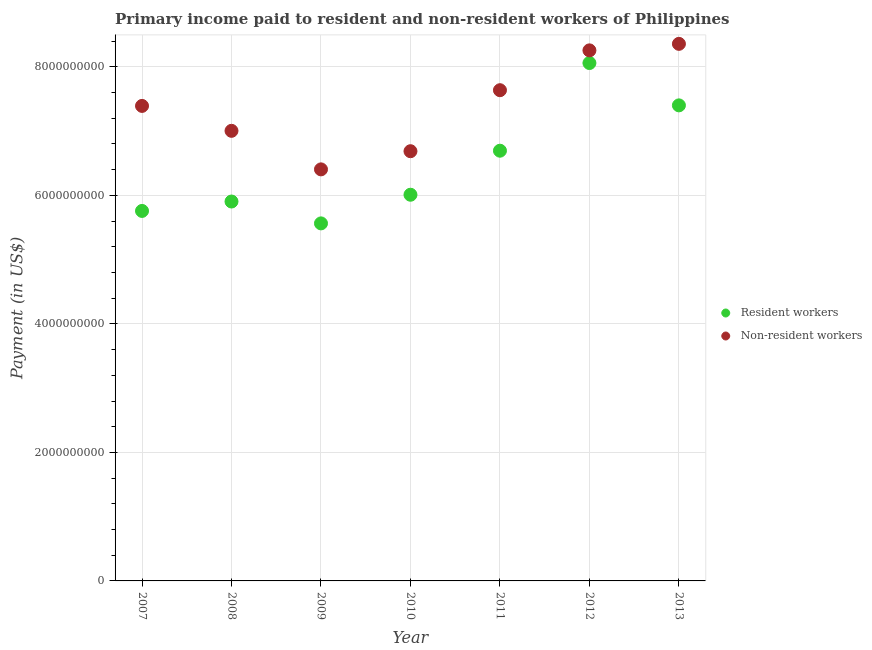Is the number of dotlines equal to the number of legend labels?
Make the answer very short. Yes. What is the payment made to resident workers in 2011?
Your response must be concise. 6.70e+09. Across all years, what is the maximum payment made to resident workers?
Offer a terse response. 8.06e+09. Across all years, what is the minimum payment made to non-resident workers?
Provide a succinct answer. 6.40e+09. What is the total payment made to resident workers in the graph?
Your response must be concise. 4.54e+1. What is the difference between the payment made to non-resident workers in 2009 and that in 2011?
Keep it short and to the point. -1.23e+09. What is the difference between the payment made to non-resident workers in 2011 and the payment made to resident workers in 2007?
Your response must be concise. 1.88e+09. What is the average payment made to resident workers per year?
Provide a succinct answer. 6.48e+09. In the year 2010, what is the difference between the payment made to non-resident workers and payment made to resident workers?
Your answer should be compact. 6.77e+08. What is the ratio of the payment made to non-resident workers in 2009 to that in 2011?
Provide a short and direct response. 0.84. Is the difference between the payment made to resident workers in 2008 and 2011 greater than the difference between the payment made to non-resident workers in 2008 and 2011?
Offer a terse response. No. What is the difference between the highest and the second highest payment made to resident workers?
Your response must be concise. 6.59e+08. What is the difference between the highest and the lowest payment made to resident workers?
Provide a succinct answer. 2.50e+09. Does the payment made to non-resident workers monotonically increase over the years?
Give a very brief answer. No. Is the payment made to resident workers strictly greater than the payment made to non-resident workers over the years?
Provide a short and direct response. No. Is the payment made to resident workers strictly less than the payment made to non-resident workers over the years?
Ensure brevity in your answer.  Yes. How many dotlines are there?
Your response must be concise. 2. Are the values on the major ticks of Y-axis written in scientific E-notation?
Make the answer very short. No. Does the graph contain grids?
Provide a succinct answer. Yes. What is the title of the graph?
Your answer should be very brief. Primary income paid to resident and non-resident workers of Philippines. What is the label or title of the Y-axis?
Your answer should be very brief. Payment (in US$). What is the Payment (in US$) of Resident workers in 2007?
Make the answer very short. 5.76e+09. What is the Payment (in US$) in Non-resident workers in 2007?
Provide a short and direct response. 7.39e+09. What is the Payment (in US$) in Resident workers in 2008?
Make the answer very short. 5.90e+09. What is the Payment (in US$) of Non-resident workers in 2008?
Keep it short and to the point. 7.00e+09. What is the Payment (in US$) in Resident workers in 2009?
Your answer should be very brief. 5.56e+09. What is the Payment (in US$) of Non-resident workers in 2009?
Give a very brief answer. 6.40e+09. What is the Payment (in US$) in Resident workers in 2010?
Offer a very short reply. 6.01e+09. What is the Payment (in US$) in Non-resident workers in 2010?
Keep it short and to the point. 6.69e+09. What is the Payment (in US$) in Resident workers in 2011?
Your answer should be very brief. 6.70e+09. What is the Payment (in US$) in Non-resident workers in 2011?
Your answer should be very brief. 7.64e+09. What is the Payment (in US$) of Resident workers in 2012?
Your answer should be compact. 8.06e+09. What is the Payment (in US$) of Non-resident workers in 2012?
Give a very brief answer. 8.26e+09. What is the Payment (in US$) in Resident workers in 2013?
Provide a short and direct response. 7.40e+09. What is the Payment (in US$) in Non-resident workers in 2013?
Give a very brief answer. 8.36e+09. Across all years, what is the maximum Payment (in US$) of Resident workers?
Provide a short and direct response. 8.06e+09. Across all years, what is the maximum Payment (in US$) in Non-resident workers?
Your answer should be compact. 8.36e+09. Across all years, what is the minimum Payment (in US$) in Resident workers?
Provide a short and direct response. 5.56e+09. Across all years, what is the minimum Payment (in US$) of Non-resident workers?
Keep it short and to the point. 6.40e+09. What is the total Payment (in US$) of Resident workers in the graph?
Your answer should be very brief. 4.54e+1. What is the total Payment (in US$) of Non-resident workers in the graph?
Keep it short and to the point. 5.17e+1. What is the difference between the Payment (in US$) of Resident workers in 2007 and that in 2008?
Offer a very short reply. -1.47e+08. What is the difference between the Payment (in US$) in Non-resident workers in 2007 and that in 2008?
Your answer should be compact. 3.88e+08. What is the difference between the Payment (in US$) in Resident workers in 2007 and that in 2009?
Provide a short and direct response. 1.94e+08. What is the difference between the Payment (in US$) in Non-resident workers in 2007 and that in 2009?
Your answer should be very brief. 9.88e+08. What is the difference between the Payment (in US$) in Resident workers in 2007 and that in 2010?
Provide a short and direct response. -2.52e+08. What is the difference between the Payment (in US$) in Non-resident workers in 2007 and that in 2010?
Keep it short and to the point. 7.05e+08. What is the difference between the Payment (in US$) in Resident workers in 2007 and that in 2011?
Keep it short and to the point. -9.37e+08. What is the difference between the Payment (in US$) in Non-resident workers in 2007 and that in 2011?
Ensure brevity in your answer.  -2.45e+08. What is the difference between the Payment (in US$) of Resident workers in 2007 and that in 2012?
Provide a short and direct response. -2.30e+09. What is the difference between the Payment (in US$) of Non-resident workers in 2007 and that in 2012?
Make the answer very short. -8.65e+08. What is the difference between the Payment (in US$) of Resident workers in 2007 and that in 2013?
Make the answer very short. -1.64e+09. What is the difference between the Payment (in US$) in Non-resident workers in 2007 and that in 2013?
Make the answer very short. -9.66e+08. What is the difference between the Payment (in US$) of Resident workers in 2008 and that in 2009?
Give a very brief answer. 3.40e+08. What is the difference between the Payment (in US$) of Non-resident workers in 2008 and that in 2009?
Your answer should be very brief. 6.00e+08. What is the difference between the Payment (in US$) in Resident workers in 2008 and that in 2010?
Offer a terse response. -1.06e+08. What is the difference between the Payment (in US$) of Non-resident workers in 2008 and that in 2010?
Offer a very short reply. 3.17e+08. What is the difference between the Payment (in US$) in Resident workers in 2008 and that in 2011?
Make the answer very short. -7.91e+08. What is the difference between the Payment (in US$) of Non-resident workers in 2008 and that in 2011?
Provide a short and direct response. -6.32e+08. What is the difference between the Payment (in US$) of Resident workers in 2008 and that in 2012?
Offer a terse response. -2.16e+09. What is the difference between the Payment (in US$) in Non-resident workers in 2008 and that in 2012?
Offer a terse response. -1.25e+09. What is the difference between the Payment (in US$) in Resident workers in 2008 and that in 2013?
Make the answer very short. -1.50e+09. What is the difference between the Payment (in US$) of Non-resident workers in 2008 and that in 2013?
Provide a short and direct response. -1.35e+09. What is the difference between the Payment (in US$) in Resident workers in 2009 and that in 2010?
Provide a short and direct response. -4.46e+08. What is the difference between the Payment (in US$) in Non-resident workers in 2009 and that in 2010?
Ensure brevity in your answer.  -2.83e+08. What is the difference between the Payment (in US$) in Resident workers in 2009 and that in 2011?
Offer a terse response. -1.13e+09. What is the difference between the Payment (in US$) in Non-resident workers in 2009 and that in 2011?
Your response must be concise. -1.23e+09. What is the difference between the Payment (in US$) of Resident workers in 2009 and that in 2012?
Your answer should be compact. -2.50e+09. What is the difference between the Payment (in US$) in Non-resident workers in 2009 and that in 2012?
Provide a succinct answer. -1.85e+09. What is the difference between the Payment (in US$) of Resident workers in 2009 and that in 2013?
Your answer should be compact. -1.84e+09. What is the difference between the Payment (in US$) of Non-resident workers in 2009 and that in 2013?
Your answer should be compact. -1.95e+09. What is the difference between the Payment (in US$) of Resident workers in 2010 and that in 2011?
Offer a very short reply. -6.85e+08. What is the difference between the Payment (in US$) of Non-resident workers in 2010 and that in 2011?
Ensure brevity in your answer.  -9.49e+08. What is the difference between the Payment (in US$) in Resident workers in 2010 and that in 2012?
Your response must be concise. -2.05e+09. What is the difference between the Payment (in US$) in Non-resident workers in 2010 and that in 2012?
Make the answer very short. -1.57e+09. What is the difference between the Payment (in US$) in Resident workers in 2010 and that in 2013?
Your answer should be very brief. -1.39e+09. What is the difference between the Payment (in US$) in Non-resident workers in 2010 and that in 2013?
Your answer should be compact. -1.67e+09. What is the difference between the Payment (in US$) of Resident workers in 2011 and that in 2012?
Provide a short and direct response. -1.36e+09. What is the difference between the Payment (in US$) of Non-resident workers in 2011 and that in 2012?
Your response must be concise. -6.20e+08. What is the difference between the Payment (in US$) in Resident workers in 2011 and that in 2013?
Offer a terse response. -7.06e+08. What is the difference between the Payment (in US$) in Non-resident workers in 2011 and that in 2013?
Offer a terse response. -7.21e+08. What is the difference between the Payment (in US$) in Resident workers in 2012 and that in 2013?
Give a very brief answer. 6.59e+08. What is the difference between the Payment (in US$) of Non-resident workers in 2012 and that in 2013?
Make the answer very short. -1.01e+08. What is the difference between the Payment (in US$) in Resident workers in 2007 and the Payment (in US$) in Non-resident workers in 2008?
Provide a succinct answer. -1.25e+09. What is the difference between the Payment (in US$) of Resident workers in 2007 and the Payment (in US$) of Non-resident workers in 2009?
Keep it short and to the point. -6.47e+08. What is the difference between the Payment (in US$) in Resident workers in 2007 and the Payment (in US$) in Non-resident workers in 2010?
Provide a succinct answer. -9.30e+08. What is the difference between the Payment (in US$) in Resident workers in 2007 and the Payment (in US$) in Non-resident workers in 2011?
Provide a succinct answer. -1.88e+09. What is the difference between the Payment (in US$) of Resident workers in 2007 and the Payment (in US$) of Non-resident workers in 2012?
Keep it short and to the point. -2.50e+09. What is the difference between the Payment (in US$) of Resident workers in 2007 and the Payment (in US$) of Non-resident workers in 2013?
Your answer should be very brief. -2.60e+09. What is the difference between the Payment (in US$) of Resident workers in 2008 and the Payment (in US$) of Non-resident workers in 2009?
Your response must be concise. -5.00e+08. What is the difference between the Payment (in US$) of Resident workers in 2008 and the Payment (in US$) of Non-resident workers in 2010?
Keep it short and to the point. -7.83e+08. What is the difference between the Payment (in US$) in Resident workers in 2008 and the Payment (in US$) in Non-resident workers in 2011?
Offer a terse response. -1.73e+09. What is the difference between the Payment (in US$) of Resident workers in 2008 and the Payment (in US$) of Non-resident workers in 2012?
Your response must be concise. -2.35e+09. What is the difference between the Payment (in US$) of Resident workers in 2008 and the Payment (in US$) of Non-resident workers in 2013?
Your answer should be compact. -2.45e+09. What is the difference between the Payment (in US$) of Resident workers in 2009 and the Payment (in US$) of Non-resident workers in 2010?
Your answer should be very brief. -1.12e+09. What is the difference between the Payment (in US$) in Resident workers in 2009 and the Payment (in US$) in Non-resident workers in 2011?
Your answer should be very brief. -2.07e+09. What is the difference between the Payment (in US$) of Resident workers in 2009 and the Payment (in US$) of Non-resident workers in 2012?
Ensure brevity in your answer.  -2.69e+09. What is the difference between the Payment (in US$) of Resident workers in 2009 and the Payment (in US$) of Non-resident workers in 2013?
Keep it short and to the point. -2.79e+09. What is the difference between the Payment (in US$) in Resident workers in 2010 and the Payment (in US$) in Non-resident workers in 2011?
Give a very brief answer. -1.63e+09. What is the difference between the Payment (in US$) of Resident workers in 2010 and the Payment (in US$) of Non-resident workers in 2012?
Provide a short and direct response. -2.25e+09. What is the difference between the Payment (in US$) in Resident workers in 2010 and the Payment (in US$) in Non-resident workers in 2013?
Ensure brevity in your answer.  -2.35e+09. What is the difference between the Payment (in US$) in Resident workers in 2011 and the Payment (in US$) in Non-resident workers in 2012?
Your answer should be very brief. -1.56e+09. What is the difference between the Payment (in US$) of Resident workers in 2011 and the Payment (in US$) of Non-resident workers in 2013?
Provide a succinct answer. -1.66e+09. What is the difference between the Payment (in US$) in Resident workers in 2012 and the Payment (in US$) in Non-resident workers in 2013?
Your answer should be very brief. -2.99e+08. What is the average Payment (in US$) of Resident workers per year?
Provide a succinct answer. 6.48e+09. What is the average Payment (in US$) of Non-resident workers per year?
Ensure brevity in your answer.  7.39e+09. In the year 2007, what is the difference between the Payment (in US$) in Resident workers and Payment (in US$) in Non-resident workers?
Your answer should be compact. -1.63e+09. In the year 2008, what is the difference between the Payment (in US$) of Resident workers and Payment (in US$) of Non-resident workers?
Give a very brief answer. -1.10e+09. In the year 2009, what is the difference between the Payment (in US$) in Resident workers and Payment (in US$) in Non-resident workers?
Keep it short and to the point. -8.41e+08. In the year 2010, what is the difference between the Payment (in US$) in Resident workers and Payment (in US$) in Non-resident workers?
Give a very brief answer. -6.77e+08. In the year 2011, what is the difference between the Payment (in US$) of Resident workers and Payment (in US$) of Non-resident workers?
Your answer should be very brief. -9.42e+08. In the year 2012, what is the difference between the Payment (in US$) in Resident workers and Payment (in US$) in Non-resident workers?
Keep it short and to the point. -1.97e+08. In the year 2013, what is the difference between the Payment (in US$) in Resident workers and Payment (in US$) in Non-resident workers?
Provide a short and direct response. -9.57e+08. What is the ratio of the Payment (in US$) in Resident workers in 2007 to that in 2008?
Your response must be concise. 0.98. What is the ratio of the Payment (in US$) in Non-resident workers in 2007 to that in 2008?
Your answer should be compact. 1.06. What is the ratio of the Payment (in US$) in Resident workers in 2007 to that in 2009?
Provide a succinct answer. 1.03. What is the ratio of the Payment (in US$) in Non-resident workers in 2007 to that in 2009?
Make the answer very short. 1.15. What is the ratio of the Payment (in US$) in Resident workers in 2007 to that in 2010?
Your answer should be very brief. 0.96. What is the ratio of the Payment (in US$) in Non-resident workers in 2007 to that in 2010?
Your response must be concise. 1.11. What is the ratio of the Payment (in US$) of Resident workers in 2007 to that in 2011?
Offer a very short reply. 0.86. What is the ratio of the Payment (in US$) of Resident workers in 2007 to that in 2012?
Offer a terse response. 0.71. What is the ratio of the Payment (in US$) of Non-resident workers in 2007 to that in 2012?
Your answer should be compact. 0.9. What is the ratio of the Payment (in US$) of Resident workers in 2007 to that in 2013?
Provide a succinct answer. 0.78. What is the ratio of the Payment (in US$) of Non-resident workers in 2007 to that in 2013?
Your response must be concise. 0.88. What is the ratio of the Payment (in US$) of Resident workers in 2008 to that in 2009?
Provide a short and direct response. 1.06. What is the ratio of the Payment (in US$) of Non-resident workers in 2008 to that in 2009?
Offer a very short reply. 1.09. What is the ratio of the Payment (in US$) of Resident workers in 2008 to that in 2010?
Give a very brief answer. 0.98. What is the ratio of the Payment (in US$) of Non-resident workers in 2008 to that in 2010?
Your answer should be very brief. 1.05. What is the ratio of the Payment (in US$) in Resident workers in 2008 to that in 2011?
Make the answer very short. 0.88. What is the ratio of the Payment (in US$) in Non-resident workers in 2008 to that in 2011?
Your response must be concise. 0.92. What is the ratio of the Payment (in US$) in Resident workers in 2008 to that in 2012?
Provide a short and direct response. 0.73. What is the ratio of the Payment (in US$) in Non-resident workers in 2008 to that in 2012?
Your answer should be compact. 0.85. What is the ratio of the Payment (in US$) in Resident workers in 2008 to that in 2013?
Keep it short and to the point. 0.8. What is the ratio of the Payment (in US$) in Non-resident workers in 2008 to that in 2013?
Provide a succinct answer. 0.84. What is the ratio of the Payment (in US$) of Resident workers in 2009 to that in 2010?
Provide a succinct answer. 0.93. What is the ratio of the Payment (in US$) in Non-resident workers in 2009 to that in 2010?
Provide a succinct answer. 0.96. What is the ratio of the Payment (in US$) in Resident workers in 2009 to that in 2011?
Your answer should be very brief. 0.83. What is the ratio of the Payment (in US$) in Non-resident workers in 2009 to that in 2011?
Give a very brief answer. 0.84. What is the ratio of the Payment (in US$) of Resident workers in 2009 to that in 2012?
Your answer should be compact. 0.69. What is the ratio of the Payment (in US$) in Non-resident workers in 2009 to that in 2012?
Offer a terse response. 0.78. What is the ratio of the Payment (in US$) in Resident workers in 2009 to that in 2013?
Give a very brief answer. 0.75. What is the ratio of the Payment (in US$) in Non-resident workers in 2009 to that in 2013?
Make the answer very short. 0.77. What is the ratio of the Payment (in US$) in Resident workers in 2010 to that in 2011?
Your answer should be very brief. 0.9. What is the ratio of the Payment (in US$) of Non-resident workers in 2010 to that in 2011?
Offer a very short reply. 0.88. What is the ratio of the Payment (in US$) in Resident workers in 2010 to that in 2012?
Offer a very short reply. 0.75. What is the ratio of the Payment (in US$) of Non-resident workers in 2010 to that in 2012?
Offer a very short reply. 0.81. What is the ratio of the Payment (in US$) of Resident workers in 2010 to that in 2013?
Your response must be concise. 0.81. What is the ratio of the Payment (in US$) of Non-resident workers in 2010 to that in 2013?
Offer a terse response. 0.8. What is the ratio of the Payment (in US$) of Resident workers in 2011 to that in 2012?
Your answer should be compact. 0.83. What is the ratio of the Payment (in US$) of Non-resident workers in 2011 to that in 2012?
Provide a short and direct response. 0.92. What is the ratio of the Payment (in US$) in Resident workers in 2011 to that in 2013?
Keep it short and to the point. 0.9. What is the ratio of the Payment (in US$) of Non-resident workers in 2011 to that in 2013?
Your response must be concise. 0.91. What is the ratio of the Payment (in US$) in Resident workers in 2012 to that in 2013?
Your answer should be very brief. 1.09. What is the ratio of the Payment (in US$) in Non-resident workers in 2012 to that in 2013?
Ensure brevity in your answer.  0.99. What is the difference between the highest and the second highest Payment (in US$) of Resident workers?
Provide a short and direct response. 6.59e+08. What is the difference between the highest and the second highest Payment (in US$) of Non-resident workers?
Make the answer very short. 1.01e+08. What is the difference between the highest and the lowest Payment (in US$) in Resident workers?
Offer a very short reply. 2.50e+09. What is the difference between the highest and the lowest Payment (in US$) in Non-resident workers?
Give a very brief answer. 1.95e+09. 